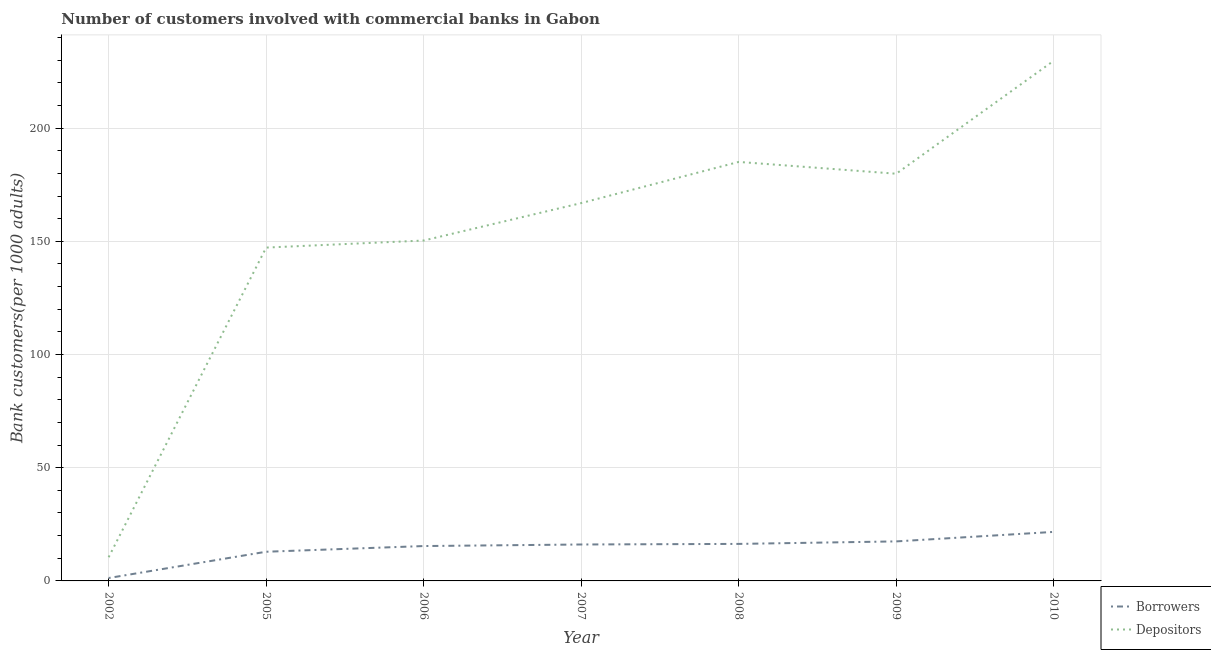How many different coloured lines are there?
Ensure brevity in your answer.  2. Is the number of lines equal to the number of legend labels?
Ensure brevity in your answer.  Yes. What is the number of depositors in 2002?
Make the answer very short. 10.46. Across all years, what is the maximum number of depositors?
Keep it short and to the point. 229.74. Across all years, what is the minimum number of depositors?
Your answer should be very brief. 10.46. What is the total number of depositors in the graph?
Offer a very short reply. 1069.54. What is the difference between the number of borrowers in 2005 and that in 2007?
Ensure brevity in your answer.  -3.2. What is the difference between the number of depositors in 2005 and the number of borrowers in 2007?
Keep it short and to the point. 131.13. What is the average number of depositors per year?
Ensure brevity in your answer.  152.79. In the year 2007, what is the difference between the number of depositors and number of borrowers?
Provide a short and direct response. 150.78. What is the ratio of the number of borrowers in 2007 to that in 2008?
Offer a very short reply. 0.98. Is the number of depositors in 2005 less than that in 2007?
Your response must be concise. Yes. What is the difference between the highest and the second highest number of depositors?
Provide a succinct answer. 44.69. What is the difference between the highest and the lowest number of borrowers?
Your response must be concise. 20.37. Is the sum of the number of borrowers in 2005 and 2009 greater than the maximum number of depositors across all years?
Your answer should be compact. No. Does the number of depositors monotonically increase over the years?
Make the answer very short. No. How many years are there in the graph?
Provide a succinct answer. 7. Does the graph contain grids?
Provide a short and direct response. Yes. Where does the legend appear in the graph?
Your response must be concise. Bottom right. How many legend labels are there?
Offer a terse response. 2. What is the title of the graph?
Your answer should be very brief. Number of customers involved with commercial banks in Gabon. What is the label or title of the X-axis?
Ensure brevity in your answer.  Year. What is the label or title of the Y-axis?
Ensure brevity in your answer.  Bank customers(per 1000 adults). What is the Bank customers(per 1000 adults) in Borrowers in 2002?
Make the answer very short. 1.28. What is the Bank customers(per 1000 adults) in Depositors in 2002?
Your answer should be very brief. 10.46. What is the Bank customers(per 1000 adults) in Borrowers in 2005?
Ensure brevity in your answer.  12.89. What is the Bank customers(per 1000 adults) of Depositors in 2005?
Ensure brevity in your answer.  147.22. What is the Bank customers(per 1000 adults) in Borrowers in 2006?
Your response must be concise. 15.4. What is the Bank customers(per 1000 adults) of Depositors in 2006?
Provide a succinct answer. 150.34. What is the Bank customers(per 1000 adults) of Borrowers in 2007?
Your response must be concise. 16.09. What is the Bank customers(per 1000 adults) in Depositors in 2007?
Your answer should be compact. 166.87. What is the Bank customers(per 1000 adults) in Borrowers in 2008?
Make the answer very short. 16.35. What is the Bank customers(per 1000 adults) of Depositors in 2008?
Offer a very short reply. 185.06. What is the Bank customers(per 1000 adults) in Borrowers in 2009?
Make the answer very short. 17.46. What is the Bank customers(per 1000 adults) in Depositors in 2009?
Give a very brief answer. 179.84. What is the Bank customers(per 1000 adults) in Borrowers in 2010?
Your response must be concise. 21.66. What is the Bank customers(per 1000 adults) in Depositors in 2010?
Keep it short and to the point. 229.74. Across all years, what is the maximum Bank customers(per 1000 adults) of Borrowers?
Provide a succinct answer. 21.66. Across all years, what is the maximum Bank customers(per 1000 adults) in Depositors?
Ensure brevity in your answer.  229.74. Across all years, what is the minimum Bank customers(per 1000 adults) of Borrowers?
Make the answer very short. 1.28. Across all years, what is the minimum Bank customers(per 1000 adults) in Depositors?
Make the answer very short. 10.46. What is the total Bank customers(per 1000 adults) of Borrowers in the graph?
Ensure brevity in your answer.  101.13. What is the total Bank customers(per 1000 adults) of Depositors in the graph?
Offer a very short reply. 1069.54. What is the difference between the Bank customers(per 1000 adults) of Borrowers in 2002 and that in 2005?
Provide a short and direct response. -11.61. What is the difference between the Bank customers(per 1000 adults) in Depositors in 2002 and that in 2005?
Your answer should be compact. -136.76. What is the difference between the Bank customers(per 1000 adults) of Borrowers in 2002 and that in 2006?
Provide a succinct answer. -14.12. What is the difference between the Bank customers(per 1000 adults) in Depositors in 2002 and that in 2006?
Your answer should be very brief. -139.88. What is the difference between the Bank customers(per 1000 adults) in Borrowers in 2002 and that in 2007?
Provide a short and direct response. -14.81. What is the difference between the Bank customers(per 1000 adults) in Depositors in 2002 and that in 2007?
Make the answer very short. -156.41. What is the difference between the Bank customers(per 1000 adults) of Borrowers in 2002 and that in 2008?
Your answer should be compact. -15.07. What is the difference between the Bank customers(per 1000 adults) of Depositors in 2002 and that in 2008?
Your answer should be very brief. -174.6. What is the difference between the Bank customers(per 1000 adults) in Borrowers in 2002 and that in 2009?
Your answer should be compact. -16.17. What is the difference between the Bank customers(per 1000 adults) in Depositors in 2002 and that in 2009?
Keep it short and to the point. -169.38. What is the difference between the Bank customers(per 1000 adults) in Borrowers in 2002 and that in 2010?
Make the answer very short. -20.37. What is the difference between the Bank customers(per 1000 adults) of Depositors in 2002 and that in 2010?
Provide a short and direct response. -219.28. What is the difference between the Bank customers(per 1000 adults) of Borrowers in 2005 and that in 2006?
Your answer should be compact. -2.51. What is the difference between the Bank customers(per 1000 adults) of Depositors in 2005 and that in 2006?
Your answer should be very brief. -3.11. What is the difference between the Bank customers(per 1000 adults) of Borrowers in 2005 and that in 2007?
Offer a very short reply. -3.2. What is the difference between the Bank customers(per 1000 adults) of Depositors in 2005 and that in 2007?
Provide a succinct answer. -19.65. What is the difference between the Bank customers(per 1000 adults) in Borrowers in 2005 and that in 2008?
Provide a short and direct response. -3.46. What is the difference between the Bank customers(per 1000 adults) in Depositors in 2005 and that in 2008?
Offer a very short reply. -37.83. What is the difference between the Bank customers(per 1000 adults) of Borrowers in 2005 and that in 2009?
Give a very brief answer. -4.57. What is the difference between the Bank customers(per 1000 adults) of Depositors in 2005 and that in 2009?
Provide a succinct answer. -32.62. What is the difference between the Bank customers(per 1000 adults) of Borrowers in 2005 and that in 2010?
Ensure brevity in your answer.  -8.77. What is the difference between the Bank customers(per 1000 adults) of Depositors in 2005 and that in 2010?
Make the answer very short. -82.52. What is the difference between the Bank customers(per 1000 adults) in Borrowers in 2006 and that in 2007?
Offer a very short reply. -0.69. What is the difference between the Bank customers(per 1000 adults) in Depositors in 2006 and that in 2007?
Keep it short and to the point. -16.54. What is the difference between the Bank customers(per 1000 adults) of Borrowers in 2006 and that in 2008?
Your answer should be very brief. -0.95. What is the difference between the Bank customers(per 1000 adults) in Depositors in 2006 and that in 2008?
Keep it short and to the point. -34.72. What is the difference between the Bank customers(per 1000 adults) of Borrowers in 2006 and that in 2009?
Ensure brevity in your answer.  -2.06. What is the difference between the Bank customers(per 1000 adults) in Depositors in 2006 and that in 2009?
Provide a succinct answer. -29.5. What is the difference between the Bank customers(per 1000 adults) in Borrowers in 2006 and that in 2010?
Your response must be concise. -6.25. What is the difference between the Bank customers(per 1000 adults) of Depositors in 2006 and that in 2010?
Provide a succinct answer. -79.41. What is the difference between the Bank customers(per 1000 adults) in Borrowers in 2007 and that in 2008?
Ensure brevity in your answer.  -0.26. What is the difference between the Bank customers(per 1000 adults) in Depositors in 2007 and that in 2008?
Provide a short and direct response. -18.18. What is the difference between the Bank customers(per 1000 adults) in Borrowers in 2007 and that in 2009?
Give a very brief answer. -1.37. What is the difference between the Bank customers(per 1000 adults) of Depositors in 2007 and that in 2009?
Make the answer very short. -12.97. What is the difference between the Bank customers(per 1000 adults) of Borrowers in 2007 and that in 2010?
Give a very brief answer. -5.56. What is the difference between the Bank customers(per 1000 adults) of Depositors in 2007 and that in 2010?
Make the answer very short. -62.87. What is the difference between the Bank customers(per 1000 adults) of Borrowers in 2008 and that in 2009?
Offer a terse response. -1.11. What is the difference between the Bank customers(per 1000 adults) of Depositors in 2008 and that in 2009?
Provide a succinct answer. 5.22. What is the difference between the Bank customers(per 1000 adults) in Borrowers in 2008 and that in 2010?
Your answer should be compact. -5.3. What is the difference between the Bank customers(per 1000 adults) in Depositors in 2008 and that in 2010?
Your answer should be compact. -44.69. What is the difference between the Bank customers(per 1000 adults) of Borrowers in 2009 and that in 2010?
Provide a short and direct response. -4.2. What is the difference between the Bank customers(per 1000 adults) of Depositors in 2009 and that in 2010?
Offer a terse response. -49.9. What is the difference between the Bank customers(per 1000 adults) in Borrowers in 2002 and the Bank customers(per 1000 adults) in Depositors in 2005?
Your answer should be compact. -145.94. What is the difference between the Bank customers(per 1000 adults) of Borrowers in 2002 and the Bank customers(per 1000 adults) of Depositors in 2006?
Your answer should be very brief. -149.06. What is the difference between the Bank customers(per 1000 adults) in Borrowers in 2002 and the Bank customers(per 1000 adults) in Depositors in 2007?
Give a very brief answer. -165.59. What is the difference between the Bank customers(per 1000 adults) of Borrowers in 2002 and the Bank customers(per 1000 adults) of Depositors in 2008?
Provide a succinct answer. -183.77. What is the difference between the Bank customers(per 1000 adults) in Borrowers in 2002 and the Bank customers(per 1000 adults) in Depositors in 2009?
Provide a short and direct response. -178.56. What is the difference between the Bank customers(per 1000 adults) in Borrowers in 2002 and the Bank customers(per 1000 adults) in Depositors in 2010?
Provide a succinct answer. -228.46. What is the difference between the Bank customers(per 1000 adults) of Borrowers in 2005 and the Bank customers(per 1000 adults) of Depositors in 2006?
Make the answer very short. -137.45. What is the difference between the Bank customers(per 1000 adults) in Borrowers in 2005 and the Bank customers(per 1000 adults) in Depositors in 2007?
Offer a terse response. -153.99. What is the difference between the Bank customers(per 1000 adults) of Borrowers in 2005 and the Bank customers(per 1000 adults) of Depositors in 2008?
Offer a very short reply. -172.17. What is the difference between the Bank customers(per 1000 adults) of Borrowers in 2005 and the Bank customers(per 1000 adults) of Depositors in 2009?
Keep it short and to the point. -166.95. What is the difference between the Bank customers(per 1000 adults) in Borrowers in 2005 and the Bank customers(per 1000 adults) in Depositors in 2010?
Your response must be concise. -216.86. What is the difference between the Bank customers(per 1000 adults) in Borrowers in 2006 and the Bank customers(per 1000 adults) in Depositors in 2007?
Your response must be concise. -151.47. What is the difference between the Bank customers(per 1000 adults) of Borrowers in 2006 and the Bank customers(per 1000 adults) of Depositors in 2008?
Provide a short and direct response. -169.66. What is the difference between the Bank customers(per 1000 adults) of Borrowers in 2006 and the Bank customers(per 1000 adults) of Depositors in 2009?
Keep it short and to the point. -164.44. What is the difference between the Bank customers(per 1000 adults) of Borrowers in 2006 and the Bank customers(per 1000 adults) of Depositors in 2010?
Your answer should be very brief. -214.34. What is the difference between the Bank customers(per 1000 adults) of Borrowers in 2007 and the Bank customers(per 1000 adults) of Depositors in 2008?
Provide a short and direct response. -168.97. What is the difference between the Bank customers(per 1000 adults) of Borrowers in 2007 and the Bank customers(per 1000 adults) of Depositors in 2009?
Keep it short and to the point. -163.75. What is the difference between the Bank customers(per 1000 adults) of Borrowers in 2007 and the Bank customers(per 1000 adults) of Depositors in 2010?
Provide a short and direct response. -213.65. What is the difference between the Bank customers(per 1000 adults) in Borrowers in 2008 and the Bank customers(per 1000 adults) in Depositors in 2009?
Provide a short and direct response. -163.49. What is the difference between the Bank customers(per 1000 adults) in Borrowers in 2008 and the Bank customers(per 1000 adults) in Depositors in 2010?
Provide a succinct answer. -213.39. What is the difference between the Bank customers(per 1000 adults) in Borrowers in 2009 and the Bank customers(per 1000 adults) in Depositors in 2010?
Ensure brevity in your answer.  -212.29. What is the average Bank customers(per 1000 adults) in Borrowers per year?
Offer a terse response. 14.45. What is the average Bank customers(per 1000 adults) in Depositors per year?
Keep it short and to the point. 152.79. In the year 2002, what is the difference between the Bank customers(per 1000 adults) in Borrowers and Bank customers(per 1000 adults) in Depositors?
Provide a succinct answer. -9.18. In the year 2005, what is the difference between the Bank customers(per 1000 adults) of Borrowers and Bank customers(per 1000 adults) of Depositors?
Ensure brevity in your answer.  -134.33. In the year 2006, what is the difference between the Bank customers(per 1000 adults) of Borrowers and Bank customers(per 1000 adults) of Depositors?
Your response must be concise. -134.94. In the year 2007, what is the difference between the Bank customers(per 1000 adults) in Borrowers and Bank customers(per 1000 adults) in Depositors?
Your answer should be compact. -150.78. In the year 2008, what is the difference between the Bank customers(per 1000 adults) in Borrowers and Bank customers(per 1000 adults) in Depositors?
Offer a terse response. -168.71. In the year 2009, what is the difference between the Bank customers(per 1000 adults) of Borrowers and Bank customers(per 1000 adults) of Depositors?
Give a very brief answer. -162.38. In the year 2010, what is the difference between the Bank customers(per 1000 adults) of Borrowers and Bank customers(per 1000 adults) of Depositors?
Your response must be concise. -208.09. What is the ratio of the Bank customers(per 1000 adults) of Borrowers in 2002 to that in 2005?
Offer a very short reply. 0.1. What is the ratio of the Bank customers(per 1000 adults) in Depositors in 2002 to that in 2005?
Provide a succinct answer. 0.07. What is the ratio of the Bank customers(per 1000 adults) of Borrowers in 2002 to that in 2006?
Ensure brevity in your answer.  0.08. What is the ratio of the Bank customers(per 1000 adults) in Depositors in 2002 to that in 2006?
Give a very brief answer. 0.07. What is the ratio of the Bank customers(per 1000 adults) of Borrowers in 2002 to that in 2007?
Offer a very short reply. 0.08. What is the ratio of the Bank customers(per 1000 adults) of Depositors in 2002 to that in 2007?
Keep it short and to the point. 0.06. What is the ratio of the Bank customers(per 1000 adults) in Borrowers in 2002 to that in 2008?
Offer a terse response. 0.08. What is the ratio of the Bank customers(per 1000 adults) of Depositors in 2002 to that in 2008?
Ensure brevity in your answer.  0.06. What is the ratio of the Bank customers(per 1000 adults) of Borrowers in 2002 to that in 2009?
Provide a short and direct response. 0.07. What is the ratio of the Bank customers(per 1000 adults) in Depositors in 2002 to that in 2009?
Your response must be concise. 0.06. What is the ratio of the Bank customers(per 1000 adults) in Borrowers in 2002 to that in 2010?
Your response must be concise. 0.06. What is the ratio of the Bank customers(per 1000 adults) of Depositors in 2002 to that in 2010?
Your response must be concise. 0.05. What is the ratio of the Bank customers(per 1000 adults) of Borrowers in 2005 to that in 2006?
Your answer should be compact. 0.84. What is the ratio of the Bank customers(per 1000 adults) in Depositors in 2005 to that in 2006?
Your answer should be very brief. 0.98. What is the ratio of the Bank customers(per 1000 adults) in Borrowers in 2005 to that in 2007?
Provide a short and direct response. 0.8. What is the ratio of the Bank customers(per 1000 adults) of Depositors in 2005 to that in 2007?
Provide a short and direct response. 0.88. What is the ratio of the Bank customers(per 1000 adults) of Borrowers in 2005 to that in 2008?
Ensure brevity in your answer.  0.79. What is the ratio of the Bank customers(per 1000 adults) in Depositors in 2005 to that in 2008?
Your answer should be compact. 0.8. What is the ratio of the Bank customers(per 1000 adults) of Borrowers in 2005 to that in 2009?
Ensure brevity in your answer.  0.74. What is the ratio of the Bank customers(per 1000 adults) of Depositors in 2005 to that in 2009?
Ensure brevity in your answer.  0.82. What is the ratio of the Bank customers(per 1000 adults) of Borrowers in 2005 to that in 2010?
Keep it short and to the point. 0.6. What is the ratio of the Bank customers(per 1000 adults) of Depositors in 2005 to that in 2010?
Make the answer very short. 0.64. What is the ratio of the Bank customers(per 1000 adults) in Borrowers in 2006 to that in 2007?
Offer a terse response. 0.96. What is the ratio of the Bank customers(per 1000 adults) of Depositors in 2006 to that in 2007?
Give a very brief answer. 0.9. What is the ratio of the Bank customers(per 1000 adults) in Borrowers in 2006 to that in 2008?
Your answer should be compact. 0.94. What is the ratio of the Bank customers(per 1000 adults) in Depositors in 2006 to that in 2008?
Provide a succinct answer. 0.81. What is the ratio of the Bank customers(per 1000 adults) of Borrowers in 2006 to that in 2009?
Your answer should be compact. 0.88. What is the ratio of the Bank customers(per 1000 adults) of Depositors in 2006 to that in 2009?
Ensure brevity in your answer.  0.84. What is the ratio of the Bank customers(per 1000 adults) of Borrowers in 2006 to that in 2010?
Your response must be concise. 0.71. What is the ratio of the Bank customers(per 1000 adults) of Depositors in 2006 to that in 2010?
Offer a terse response. 0.65. What is the ratio of the Bank customers(per 1000 adults) of Borrowers in 2007 to that in 2008?
Ensure brevity in your answer.  0.98. What is the ratio of the Bank customers(per 1000 adults) of Depositors in 2007 to that in 2008?
Your answer should be very brief. 0.9. What is the ratio of the Bank customers(per 1000 adults) of Borrowers in 2007 to that in 2009?
Your answer should be compact. 0.92. What is the ratio of the Bank customers(per 1000 adults) in Depositors in 2007 to that in 2009?
Your response must be concise. 0.93. What is the ratio of the Bank customers(per 1000 adults) in Borrowers in 2007 to that in 2010?
Keep it short and to the point. 0.74. What is the ratio of the Bank customers(per 1000 adults) in Depositors in 2007 to that in 2010?
Your response must be concise. 0.73. What is the ratio of the Bank customers(per 1000 adults) in Borrowers in 2008 to that in 2009?
Your answer should be compact. 0.94. What is the ratio of the Bank customers(per 1000 adults) of Borrowers in 2008 to that in 2010?
Your answer should be compact. 0.76. What is the ratio of the Bank customers(per 1000 adults) in Depositors in 2008 to that in 2010?
Keep it short and to the point. 0.81. What is the ratio of the Bank customers(per 1000 adults) in Borrowers in 2009 to that in 2010?
Keep it short and to the point. 0.81. What is the ratio of the Bank customers(per 1000 adults) of Depositors in 2009 to that in 2010?
Keep it short and to the point. 0.78. What is the difference between the highest and the second highest Bank customers(per 1000 adults) of Borrowers?
Your response must be concise. 4.2. What is the difference between the highest and the second highest Bank customers(per 1000 adults) of Depositors?
Offer a very short reply. 44.69. What is the difference between the highest and the lowest Bank customers(per 1000 adults) in Borrowers?
Provide a short and direct response. 20.37. What is the difference between the highest and the lowest Bank customers(per 1000 adults) in Depositors?
Provide a succinct answer. 219.28. 